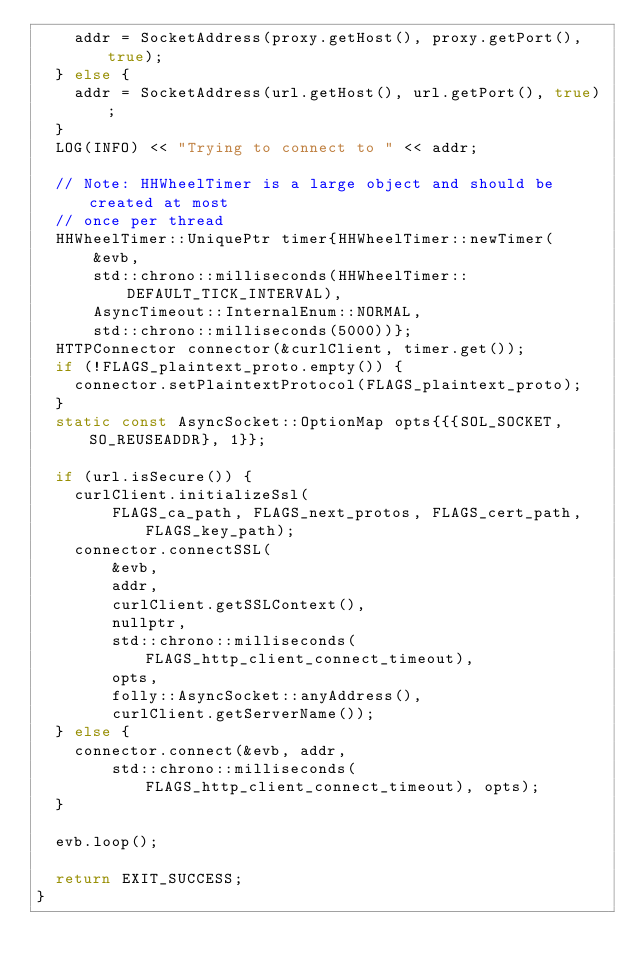Convert code to text. <code><loc_0><loc_0><loc_500><loc_500><_C++_>    addr = SocketAddress(proxy.getHost(), proxy.getPort(), true);
  } else {
    addr = SocketAddress(url.getHost(), url.getPort(), true);
  }
  LOG(INFO) << "Trying to connect to " << addr;

  // Note: HHWheelTimer is a large object and should be created at most
  // once per thread
  HHWheelTimer::UniquePtr timer{HHWheelTimer::newTimer(
      &evb,
      std::chrono::milliseconds(HHWheelTimer::DEFAULT_TICK_INTERVAL),
      AsyncTimeout::InternalEnum::NORMAL,
      std::chrono::milliseconds(5000))};
  HTTPConnector connector(&curlClient, timer.get());
  if (!FLAGS_plaintext_proto.empty()) {
    connector.setPlaintextProtocol(FLAGS_plaintext_proto);
  }
  static const AsyncSocket::OptionMap opts{{{SOL_SOCKET, SO_REUSEADDR}, 1}};

  if (url.isSecure()) {
    curlClient.initializeSsl(
        FLAGS_ca_path, FLAGS_next_protos, FLAGS_cert_path, FLAGS_key_path);
    connector.connectSSL(
        &evb,
        addr,
        curlClient.getSSLContext(),
        nullptr,
        std::chrono::milliseconds(FLAGS_http_client_connect_timeout),
        opts,
        folly::AsyncSocket::anyAddress(),
        curlClient.getServerName());
  } else {
    connector.connect(&evb, addr,
        std::chrono::milliseconds(FLAGS_http_client_connect_timeout), opts);
  }

  evb.loop();

  return EXIT_SUCCESS;
}
</code> 